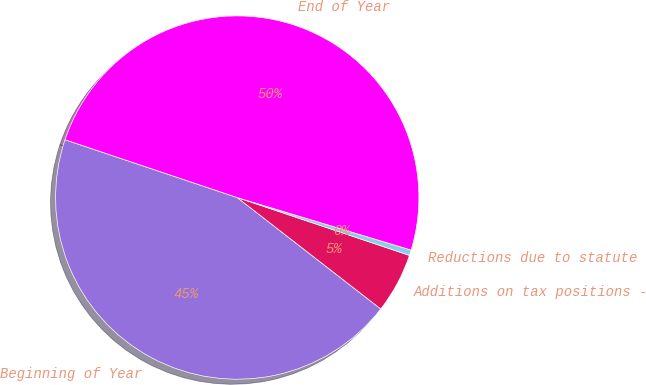Convert chart to OTSL. <chart><loc_0><loc_0><loc_500><loc_500><pie_chart><fcel>Beginning of Year<fcel>Additions on tax positions -<fcel>Reductions due to statute<fcel>End of Year<nl><fcel>44.65%<fcel>5.35%<fcel>0.49%<fcel>49.51%<nl></chart> 